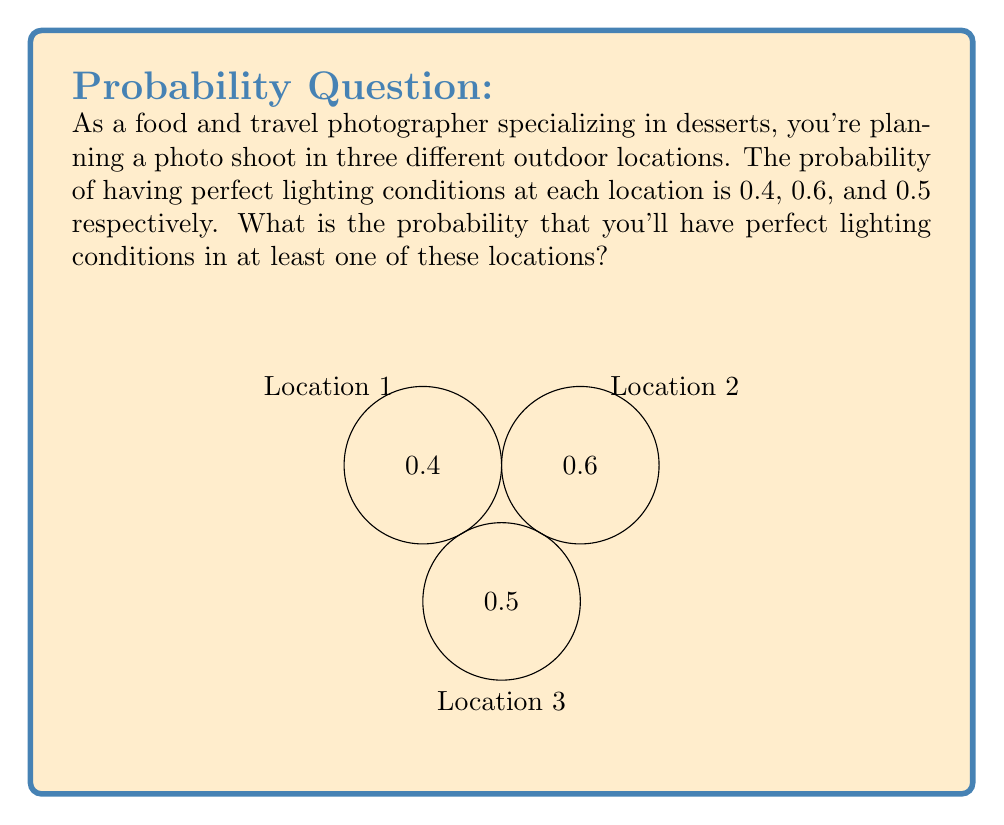Provide a solution to this math problem. Let's approach this step-by-step using the concept of probability:

1) First, let's calculate the probability of not having perfect lighting conditions at each location:
   Location 1: $1 - 0.4 = 0.6$
   Location 2: $1 - 0.6 = 0.4$
   Location 3: $1 - 0.5 = 0.5$

2) The probability of not having perfect lighting conditions in any of the locations is the product of these probabilities:
   $P(\text{no perfect lighting}) = 0.6 \times 0.4 \times 0.5 = 0.12$

3) Therefore, the probability of having perfect lighting conditions in at least one location is the complement of this probability:
   $P(\text{at least one perfect}) = 1 - P(\text{no perfect lighting})$
   $= 1 - 0.12 = 0.88$

4) We can also calculate this using the inclusion-exclusion principle:
   $P(A \cup B \cup C) = P(A) + P(B) + P(C) - P(A \cap B) - P(A \cap C) - P(B \cap C) + P(A \cap B \cap C)$
   
   Where $A$, $B$, and $C$ represent perfect lighting at each location.
   
   $= 0.4 + 0.6 + 0.5 - (0.4 \times 0.6) - (0.4 \times 0.5) - (0.6 \times 0.5) + (0.4 \times 0.6 \times 0.5)$
   $= 1.5 - 0.24 - 0.2 - 0.3 + 0.12$
   $= 0.88$

Both methods yield the same result, confirming our calculation.
Answer: 0.88 